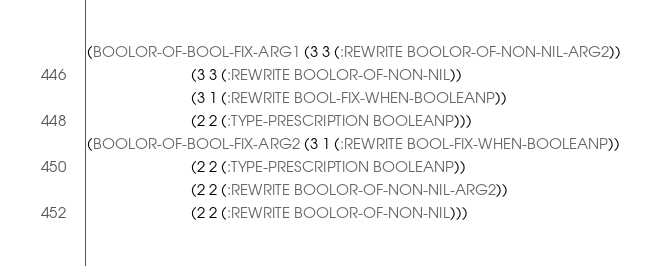Convert code to text. <code><loc_0><loc_0><loc_500><loc_500><_Lisp_>(BOOLOR-OF-BOOL-FIX-ARG1 (3 3 (:REWRITE BOOLOR-OF-NON-NIL-ARG2))
                         (3 3 (:REWRITE BOOLOR-OF-NON-NIL))
                         (3 1 (:REWRITE BOOL-FIX-WHEN-BOOLEANP))
                         (2 2 (:TYPE-PRESCRIPTION BOOLEANP)))
(BOOLOR-OF-BOOL-FIX-ARG2 (3 1 (:REWRITE BOOL-FIX-WHEN-BOOLEANP))
                         (2 2 (:TYPE-PRESCRIPTION BOOLEANP))
                         (2 2 (:REWRITE BOOLOR-OF-NON-NIL-ARG2))
                         (2 2 (:REWRITE BOOLOR-OF-NON-NIL)))
</code> 